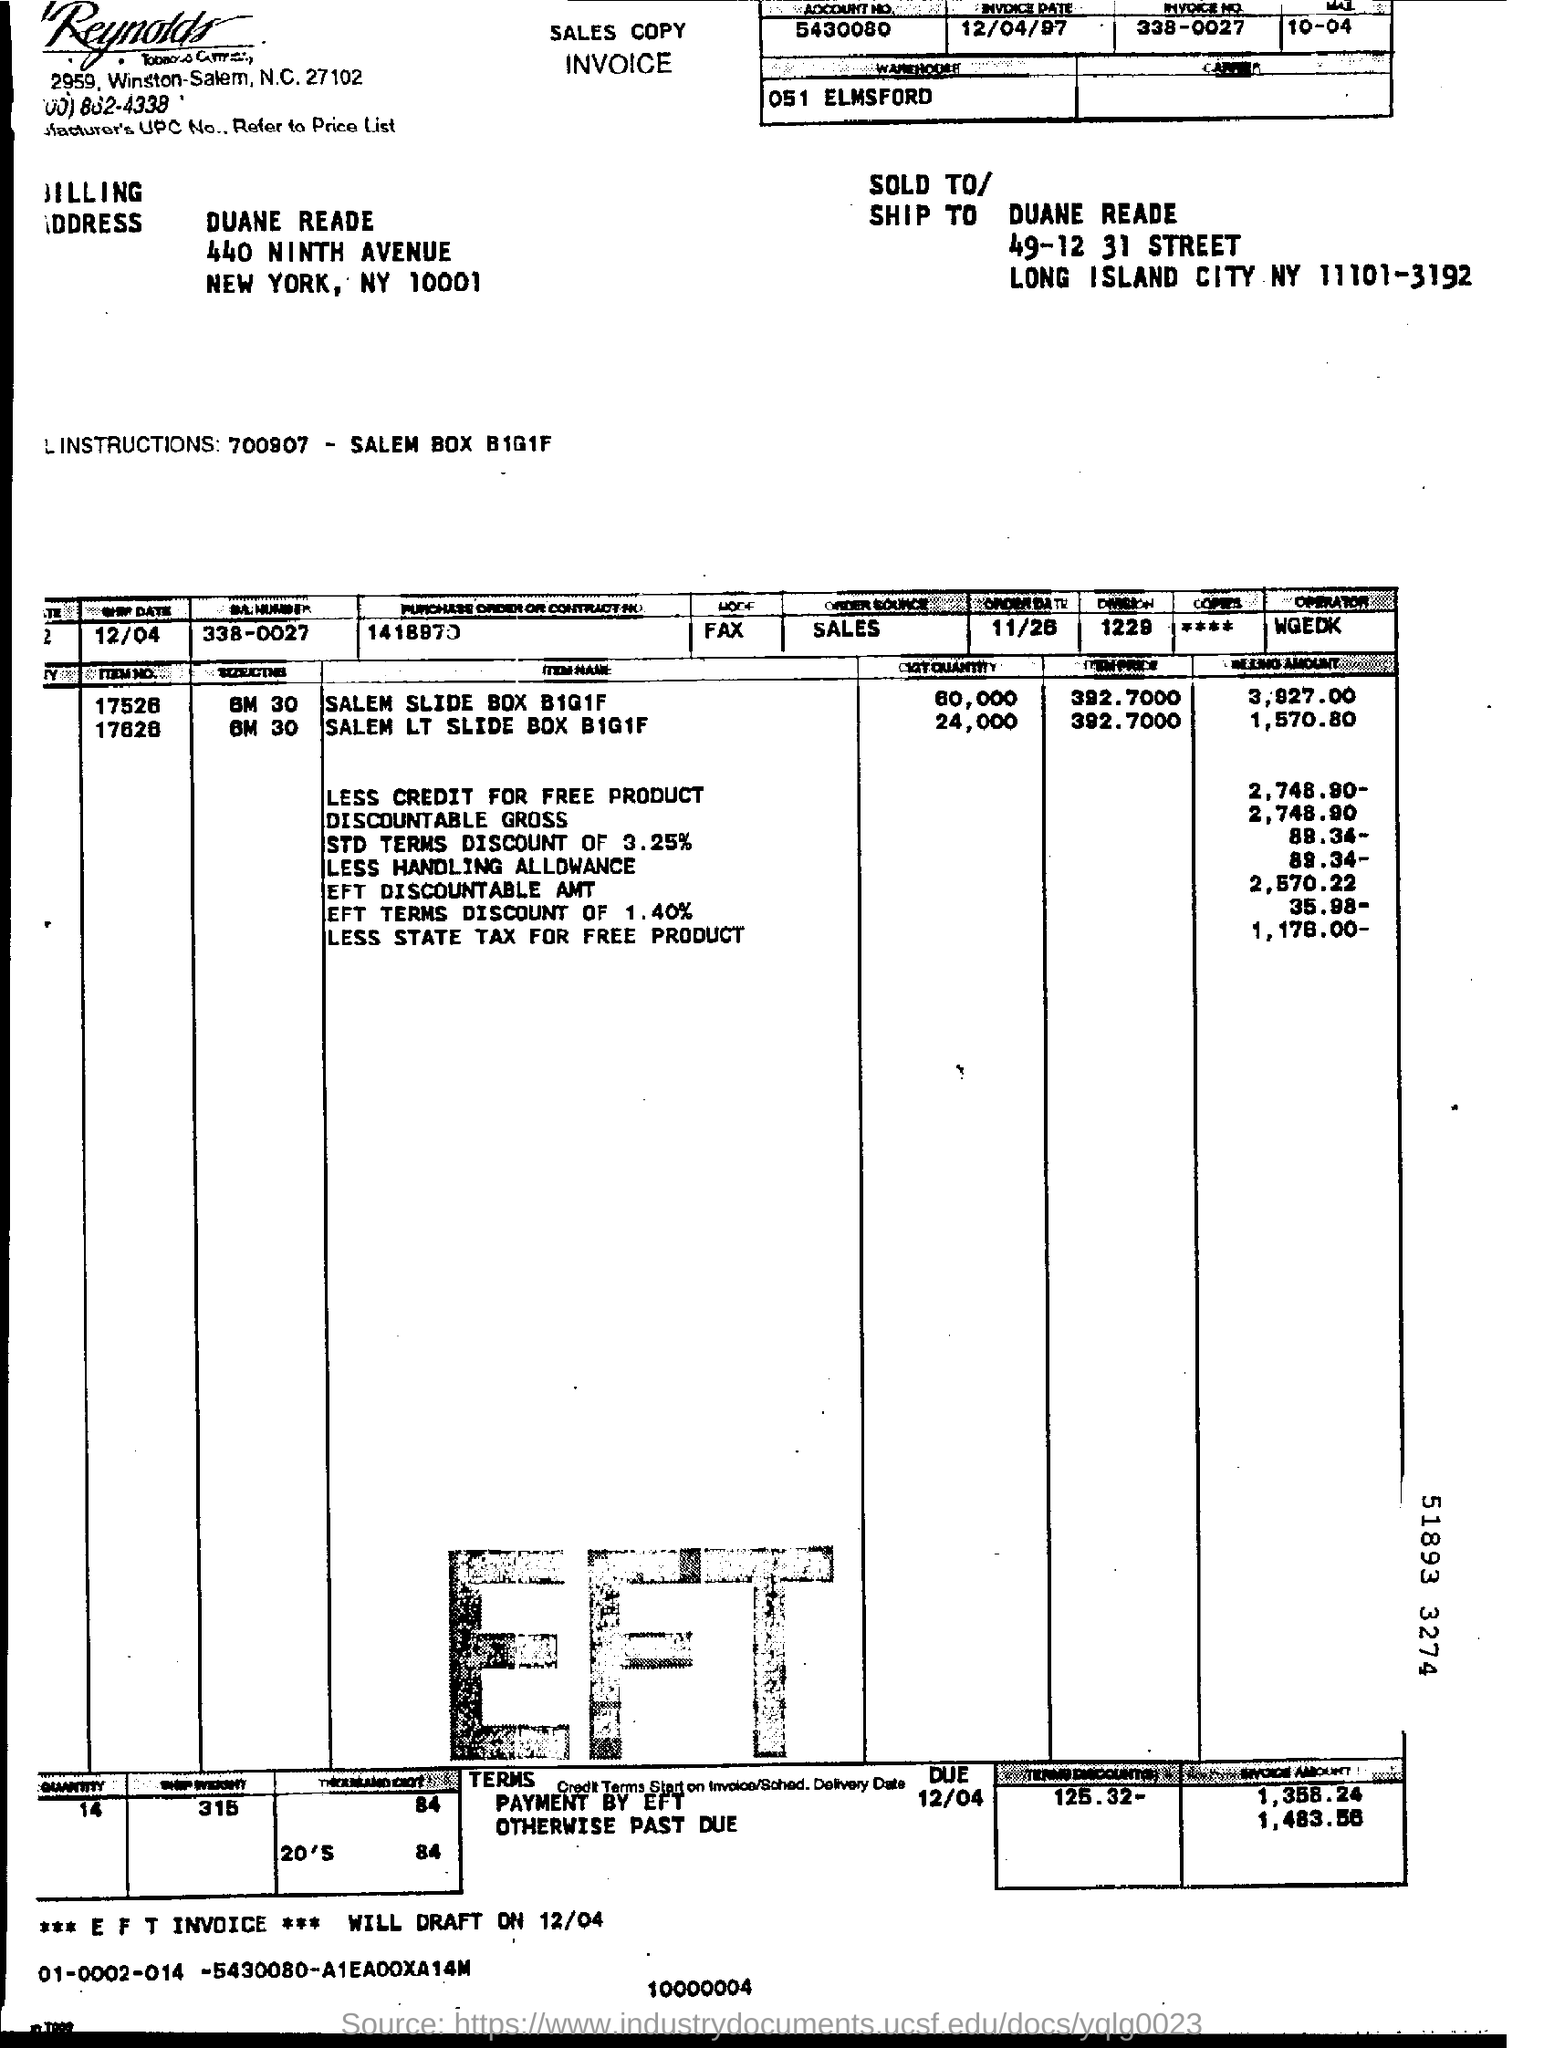List a handful of essential elements in this visual. The invoice is dated April 12, 1997. The invoice number is 338-0027. Could you please provide the account number, which is 5430080... 